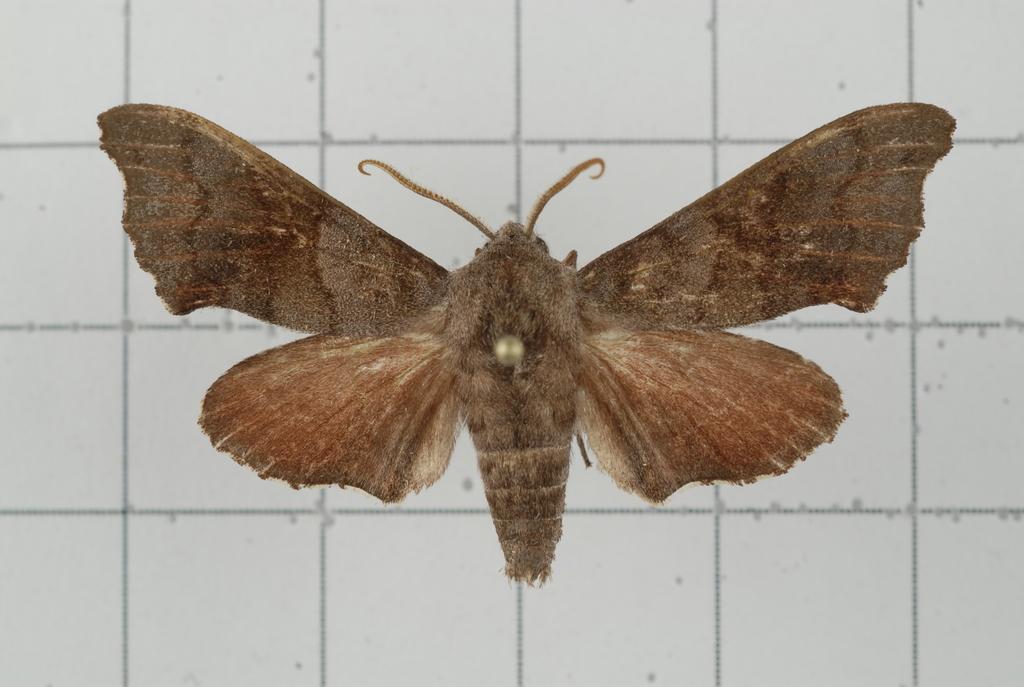Describe this image in one or two sentences. In this image there is a butterfly on the floor. 